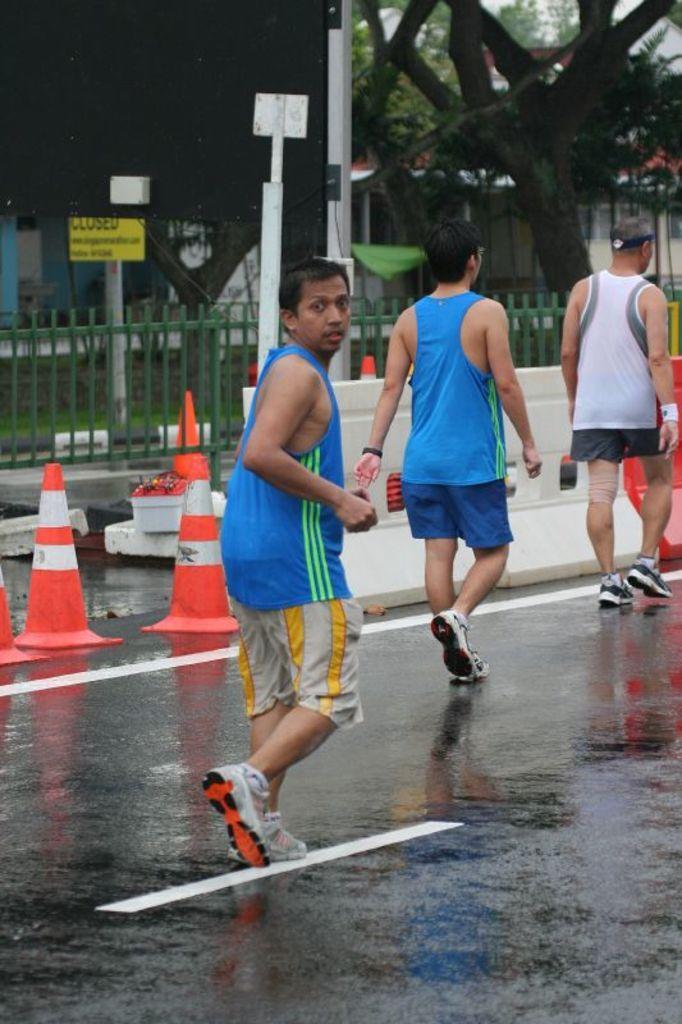In one or two sentences, can you explain what this image depicts? This man running and these two people are walking. We can see traffic cones on the road. In the background we can see fence,boards on poles,grass,trees and house. 